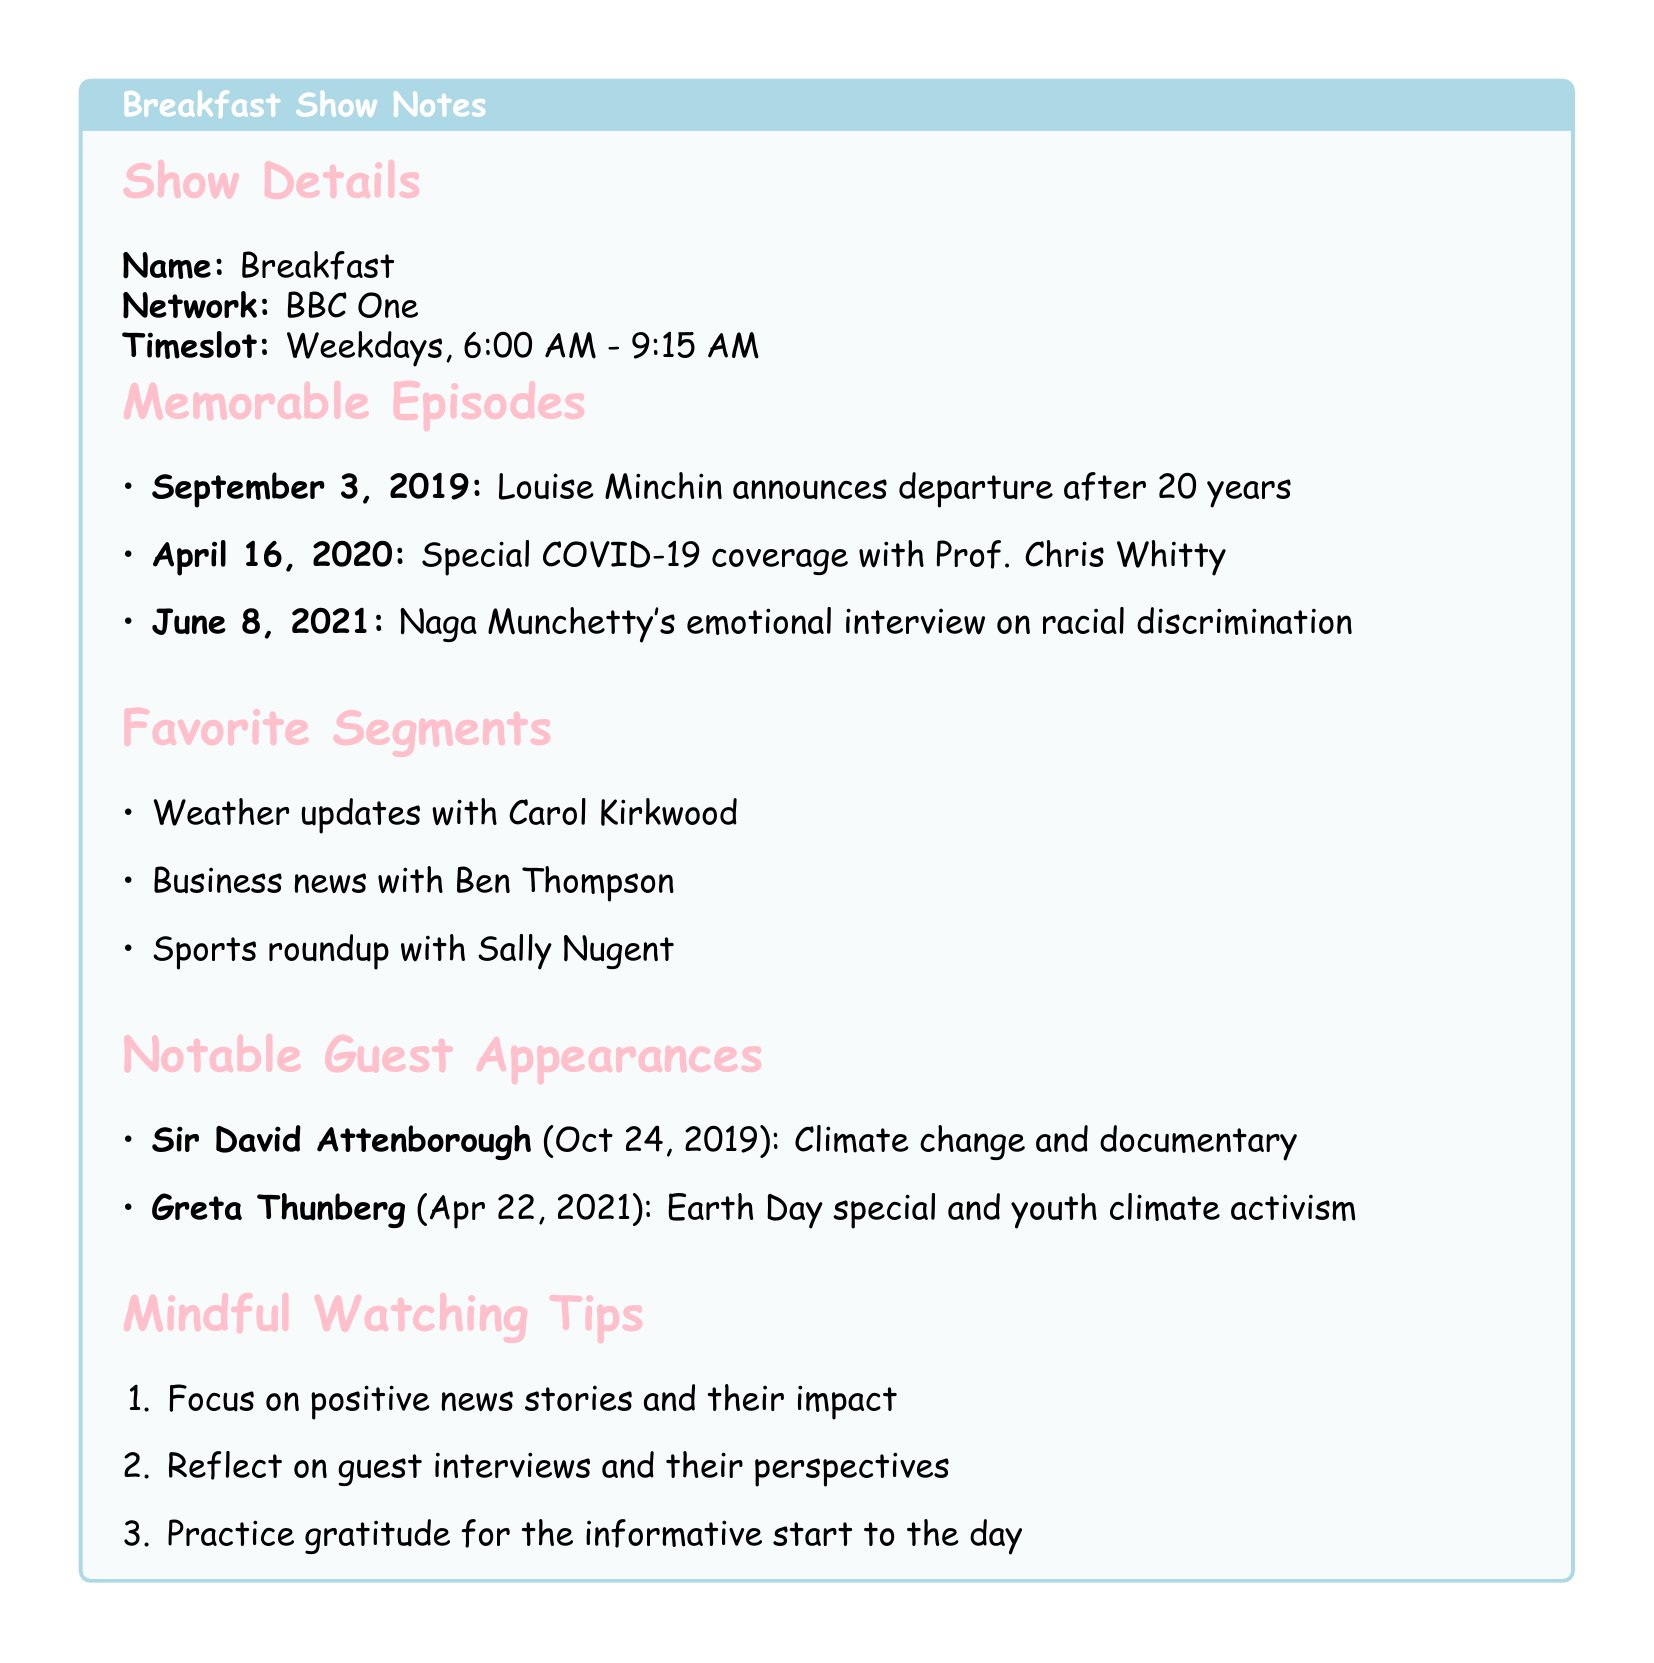what is the name of the show? The name of the show is provided under the show details section.
Answer: Breakfast who announced her departure from the show? The document highlights a memorable episode where Louise Minchin announces her departure from the show.
Answer: Louise Minchin when did the special COVID-19 coverage air? The date for the special COVID-19 coverage is mentioned in the memorable episodes section.
Answer: April 16, 2020 who interviewed Baroness Doreen Lawrence? The document states that Naga Munchetty conducted an emotional interview about racial discrimination.
Answer: Naga Munchetty what is one of the favorite segments featuring Carol Kirkwood? The favorite segments section includes various segments, one of which features Carol Kirkwood.
Answer: Weather updates who was the guest appearance on October 24, 2019? The notable guest appearances section lists Sir David Attenborough on that date.
Answer: Sir David Attenborough what is a tip for mindful watching? The document outlines tips for mindful watching, including one that emphasizes focusing on positive news stories.
Answer: Focus on positive news stories and their impact how many memorable episodes are listed? The document contains three highlighted memorable episodes in the relevant section.
Answer: Three 